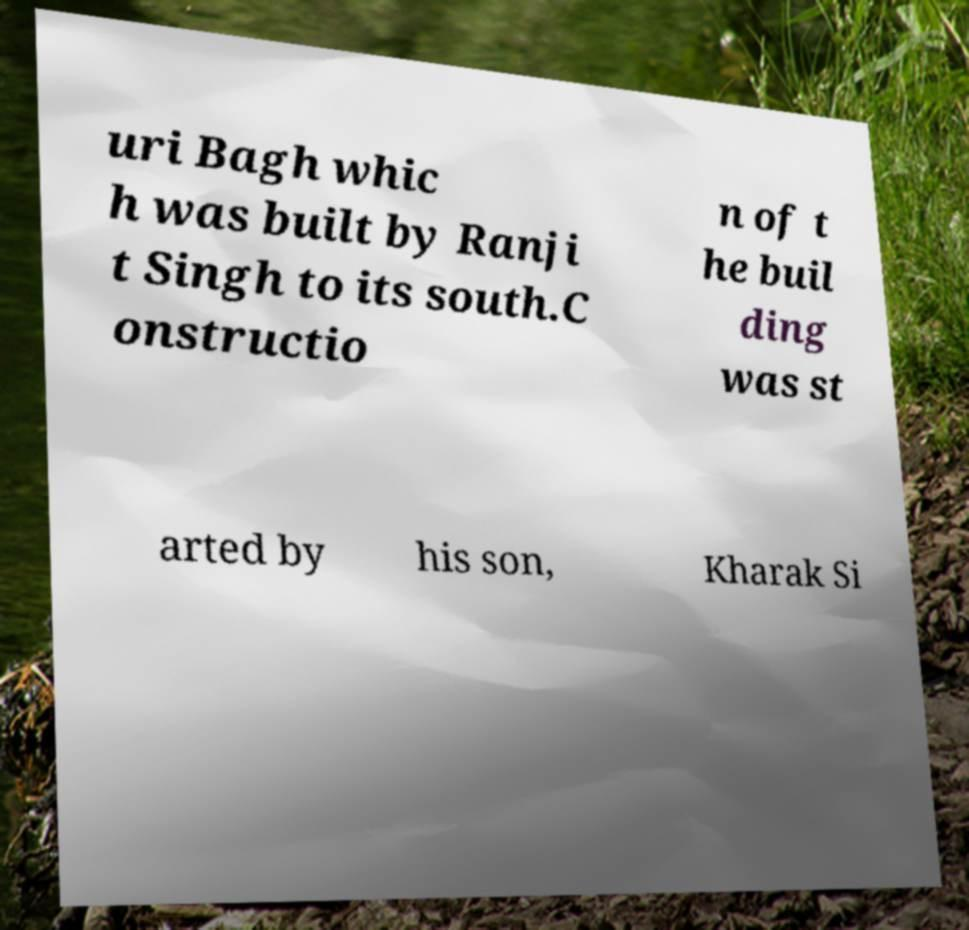Could you assist in decoding the text presented in this image and type it out clearly? uri Bagh whic h was built by Ranji t Singh to its south.C onstructio n of t he buil ding was st arted by his son, Kharak Si 